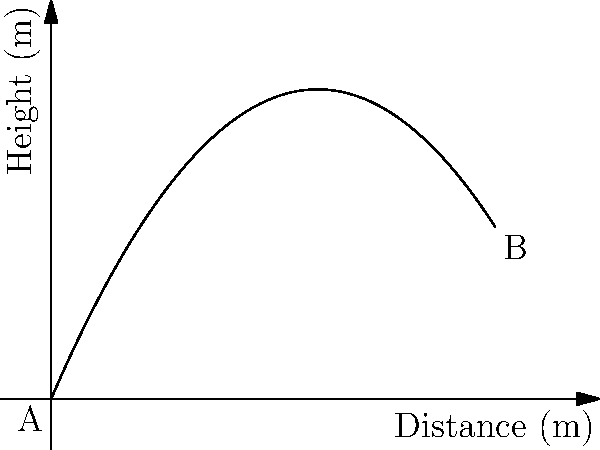The graph shows the trajectory of a curveball thrown from point A to point B. If the horizontal distance between A and B is 10 meters, what is the maximum height reached by the ball during its flight? To find the maximum height of the curveball's trajectory, we need to follow these steps:

1) The trajectory of the curveball is represented by a quadratic function. From the graph, we can see it's in the form:

   $f(x) = -ax^2 + bx + c$

   where $a$, $b$, and $c$ are constants, and $x$ is the horizontal distance.

2) The maximum point of a parabola occurs at the vertex. For a quadratic function in the form $f(x) = -ax^2 + bx + c$, the x-coordinate of the vertex is given by:

   $x = \frac{b}{2a}$

3) To find $a$ and $b$, we can use the information given:
   - The ball starts at (0,0) and ends at (10, f(10))
   - The parabola opens downward

4) Using these conditions, we can estimate the function to be approximately:

   $f(x) = -0.05x^2 + 0.6x$

5) Now we can find the x-coordinate of the vertex:

   $x = \frac{0.6}{2(0.05)} = 6$ meters

6) To find the maximum height, we substitute this x-value back into our function:

   $f(6) = -0.05(6)^2 + 0.6(6) = -1.8 + 3.6 = 1.8$ meters

Therefore, the maximum height reached by the ball is approximately 1.8 meters.
Answer: 1.8 meters 